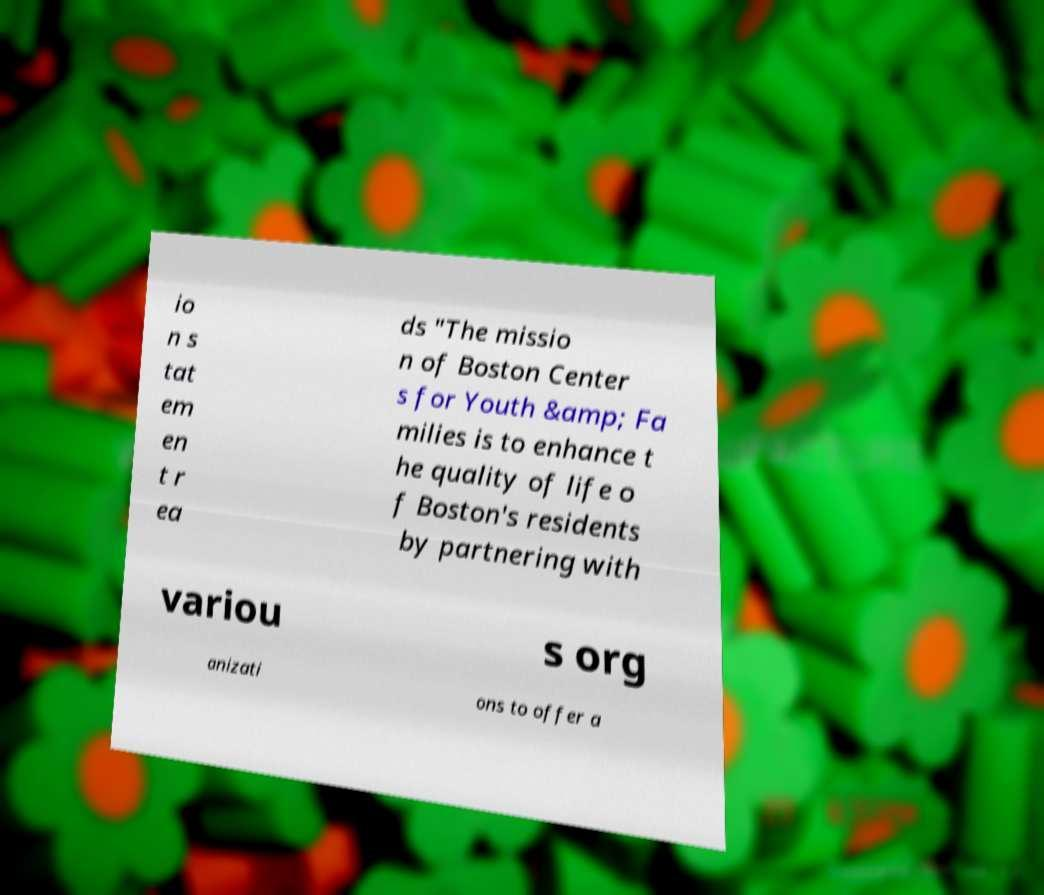Please identify and transcribe the text found in this image. io n s tat em en t r ea ds "The missio n of Boston Center s for Youth &amp; Fa milies is to enhance t he quality of life o f Boston's residents by partnering with variou s org anizati ons to offer a 